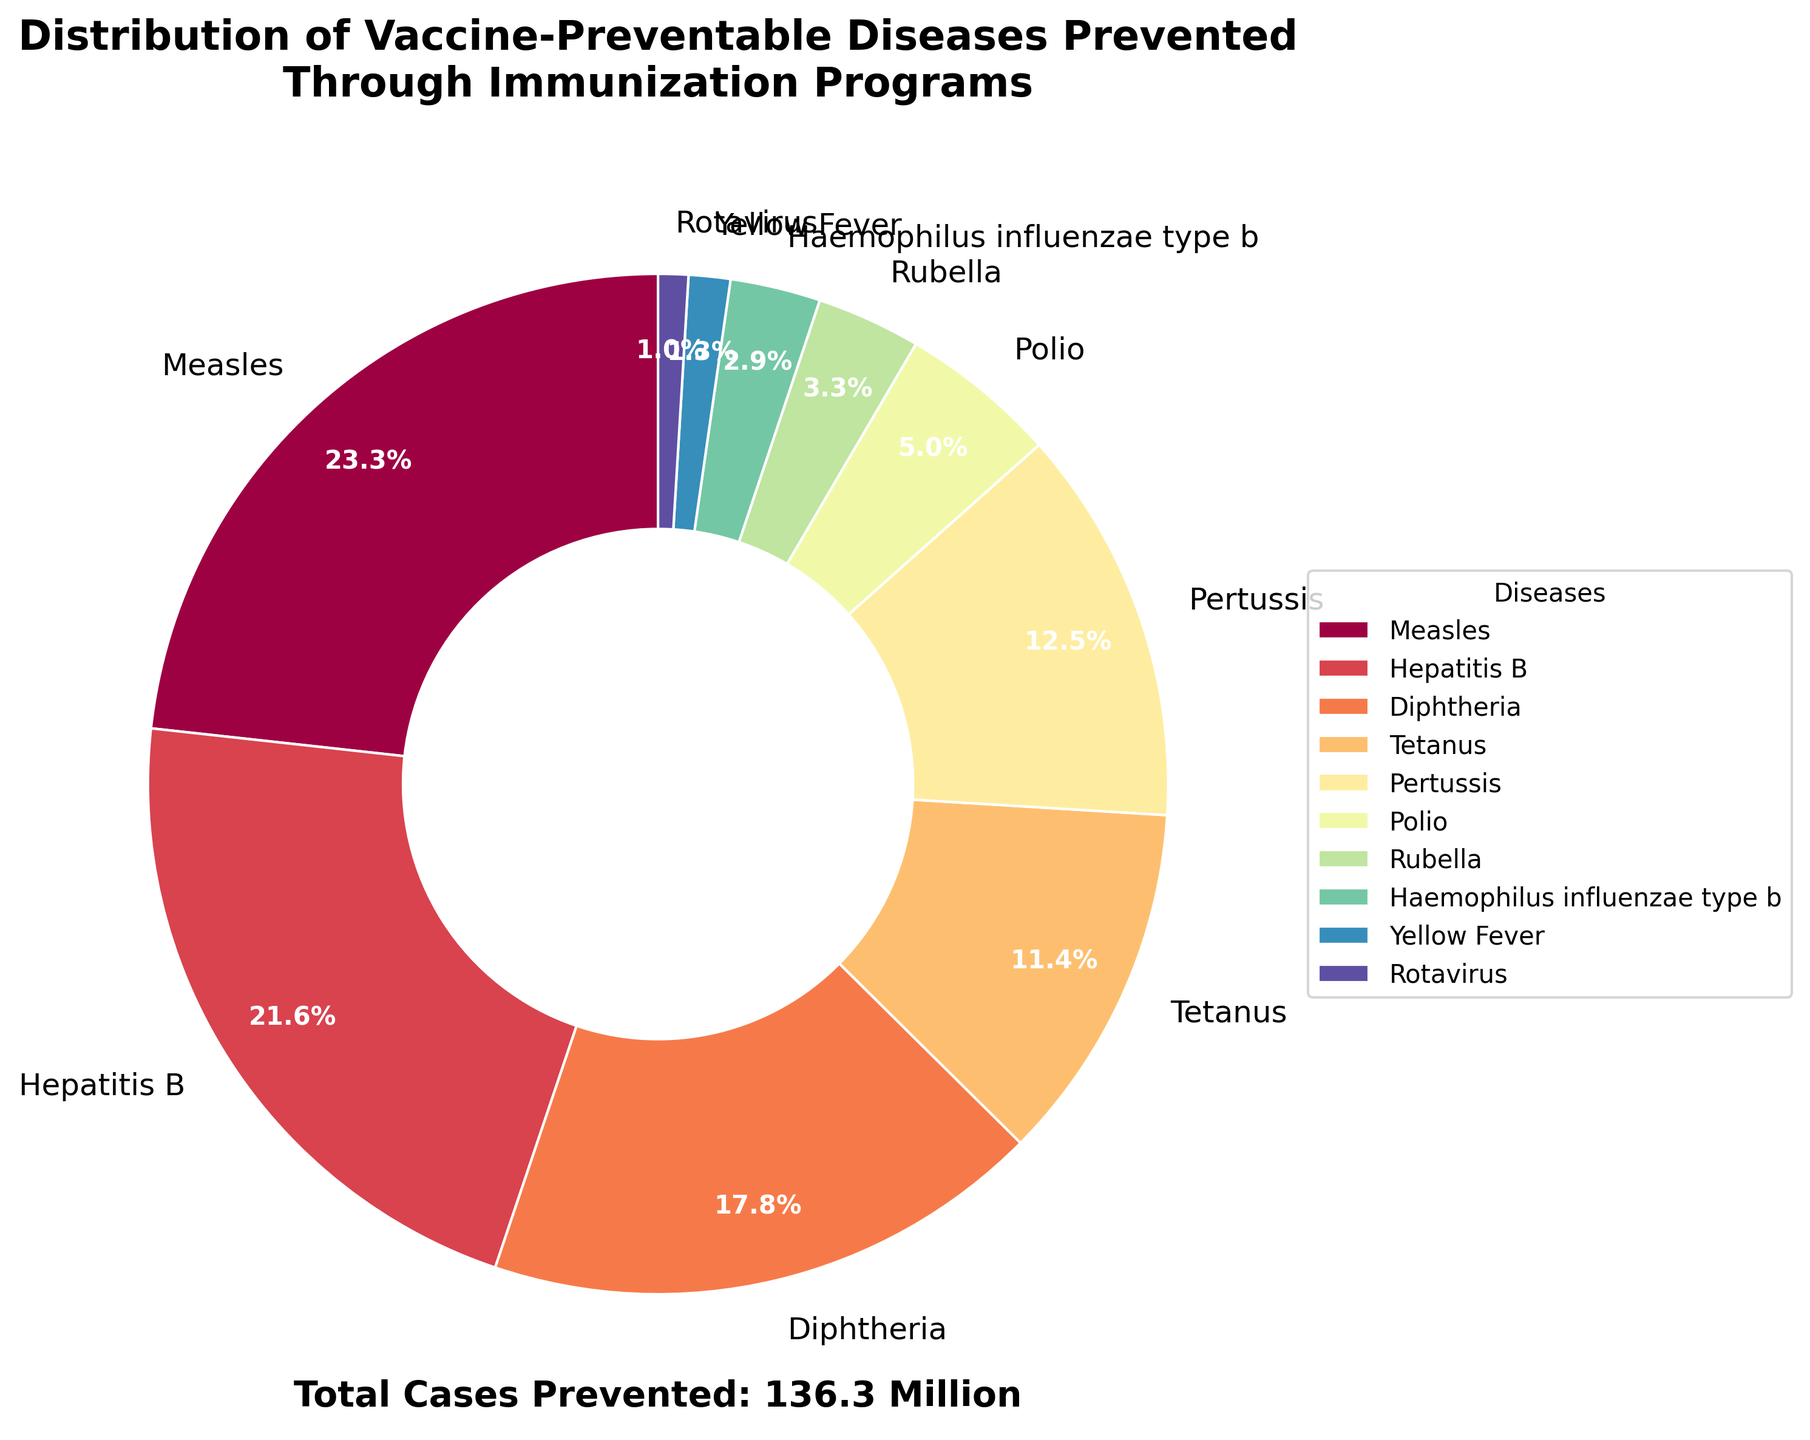What percentage of cases prevented are due to Measles? From the pie chart, the percentage corresponding to Measles is directly labeled as 31.7%, which represents the portion of cases prevented by Measles immunization.
Answer: 31.7% How many million cases of Polio and Rubella combined are prevented? The pie chart shows the cases prevented for Polio (6.8 million) and Rubella (4.5 million). Adding these figures gives 6.8 + 4.5 = 11.3 million cases prevented.
Answer: 11.3 million Which disease has the second highest number of cases prevented? Visually, the second largest segment in the pie chart after Measles (31.7 million) is Hepatitis B with 29.4 million cases prevented.
Answer: Hepatitis B How does the number of cases prevented by Pertussis compare to Tetanus? From the pie chart, Pertussis prevents 17.1 million cases while Tetanus prevents 15.6 million cases. Therefore, Pertussis prevents more cases than Tetanus by 17.1 - 15.6 = 1.5 million cases.
Answer: Pertussis prevents 1.5 million more cases What is the total number of cases prevented by vaccines for Yellow Fever, Rotavirus, and Haemophilus influenzae type b? The pie chart indicates the cases prevented for Yellow Fever (1.8 million), Rotavirus (1.3 million), and Haemophilus influenzae type b (3.9 million). Adding these together gives 1.8 + 1.3 + 3.9 = 7.0 million cases prevented.
Answer: 7.0 million What fraction of the total cases prevented is due to Hepatitis B? The chart states that Hepatitis B prevents 29.4 million cases out of a total of approximately 136.3 million cases (sum of all disease cases prevented), so the fraction is 29.4 / 136.3 ≈ 0.216. This simplifies to approximately 21.6% when expressed as a percentage.
Answer: Approximately 21.6% Which disease has the smallest proportion in the pie chart, and what is this proportion? The smallest segment in the pie chart corresponds to Rotavirus, which prevents 1.3 million cases. This is the smallest number among all diseases listed.
Answer: Rotavirus with 1.3 million cases If you sum the cases prevented by Measles and Diphtheria, how does it compare to the cases prevented by Hepatitis B and Tetanus combined? Measles (31.7 million) + Diphtheria (24.2 million) = 55.9 million. Hepatitis B (29.4 million) + Tetanus (15.6 million) = 45.0 million. Comparing these two sums, Measles and Diphtheria combined prevent more cases.
Answer: Measles and Diphtheria prevent 10.9 million more cases Which color represents Poliovirus prevention, and what percentage of total cases does it constitute? The color for Poliovirus can be identified from the corresponding wedge in the pie chart, which is visually distinct. The labeled percentage for Polio prevention is 6.8 million, which is equivalent to 5.0% of the total cases prevented.
Answer: Red, 5.0% 